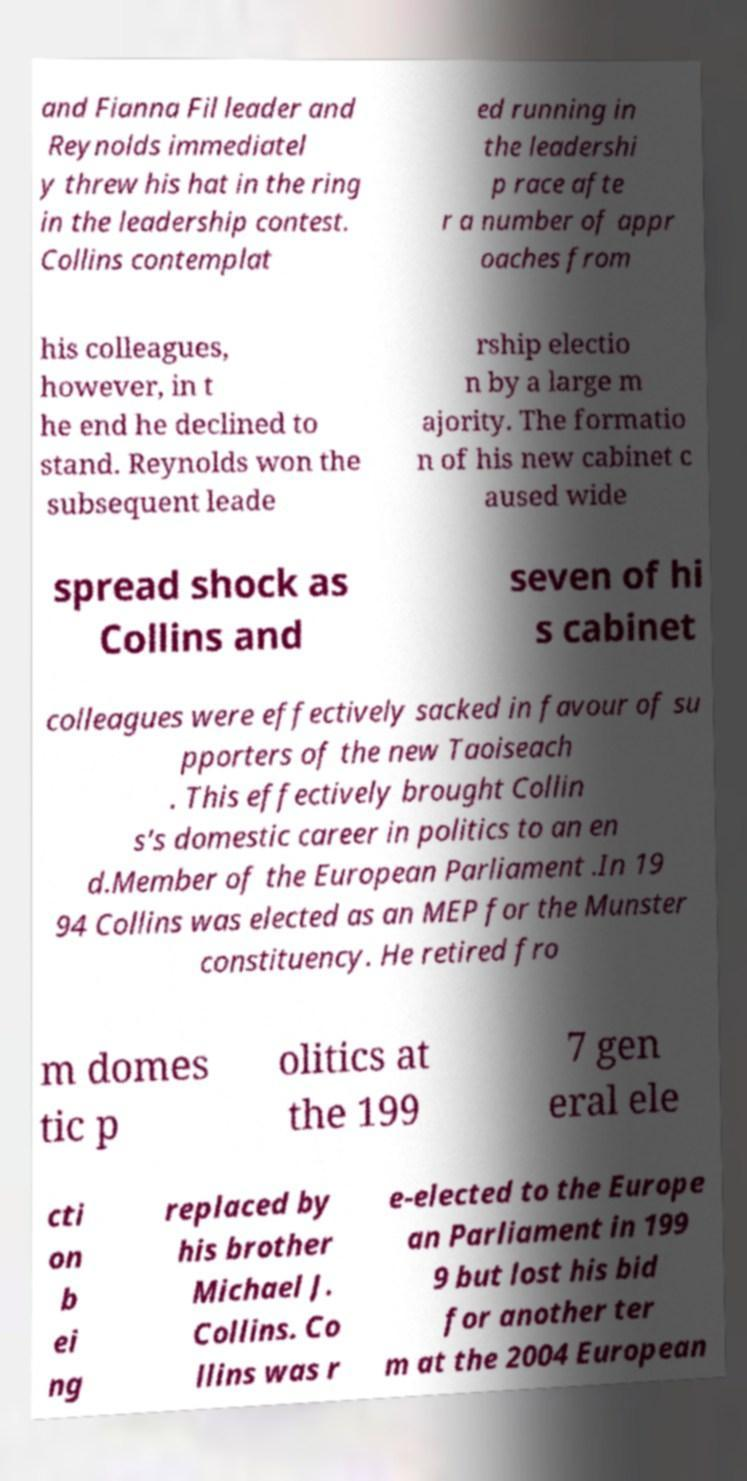What messages or text are displayed in this image? I need them in a readable, typed format. and Fianna Fil leader and Reynolds immediatel y threw his hat in the ring in the leadership contest. Collins contemplat ed running in the leadershi p race afte r a number of appr oaches from his colleagues, however, in t he end he declined to stand. Reynolds won the subsequent leade rship electio n by a large m ajority. The formatio n of his new cabinet c aused wide spread shock as Collins and seven of hi s cabinet colleagues were effectively sacked in favour of su pporters of the new Taoiseach . This effectively brought Collin s's domestic career in politics to an en d.Member of the European Parliament .In 19 94 Collins was elected as an MEP for the Munster constituency. He retired fro m domes tic p olitics at the 199 7 gen eral ele cti on b ei ng replaced by his brother Michael J. Collins. Co llins was r e-elected to the Europe an Parliament in 199 9 but lost his bid for another ter m at the 2004 European 